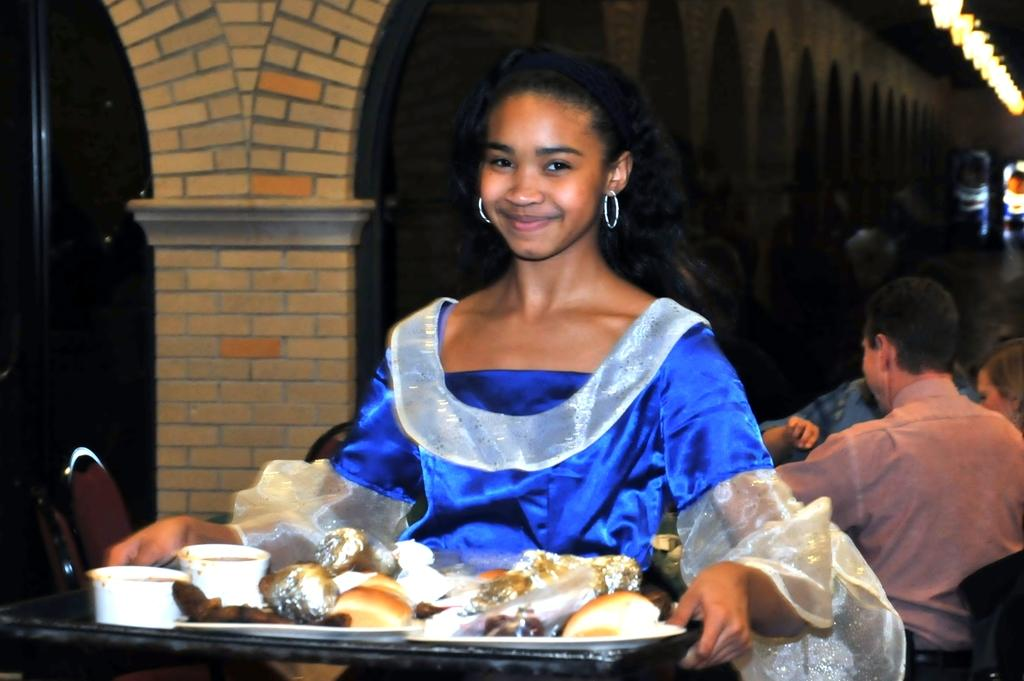Who is the main subject in the image? There is a girl in the image. What is the girl doing in the image? The girl is smiling and holding a tray. What is on the tray that the girl is holding? There are food items on the tray. Can you describe the setting of the image? There are people in the background of the image. What book is the girl reading in the image? There is no book present in the image; the girl is holding a tray with food items. Can you see a flame coming from the tray in the image? No, there is no flame visible in the image. 